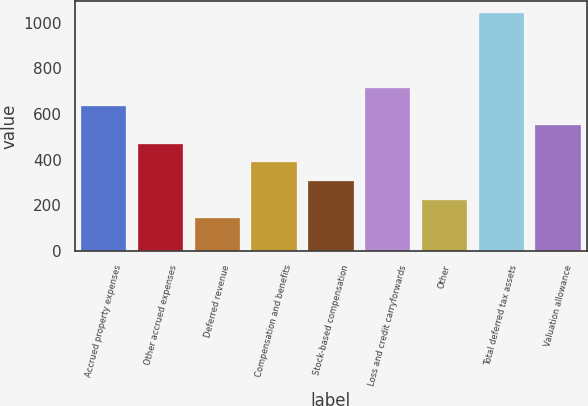<chart> <loc_0><loc_0><loc_500><loc_500><bar_chart><fcel>Accrued property expenses<fcel>Other accrued expenses<fcel>Deferred revenue<fcel>Compensation and benefits<fcel>Stock-based compensation<fcel>Loss and credit carryforwards<fcel>Other<fcel>Total deferred tax assets<fcel>Valuation allowance<nl><fcel>633.3<fcel>469.5<fcel>141.9<fcel>387.6<fcel>305.7<fcel>715.2<fcel>223.8<fcel>1042.8<fcel>551.4<nl></chart> 